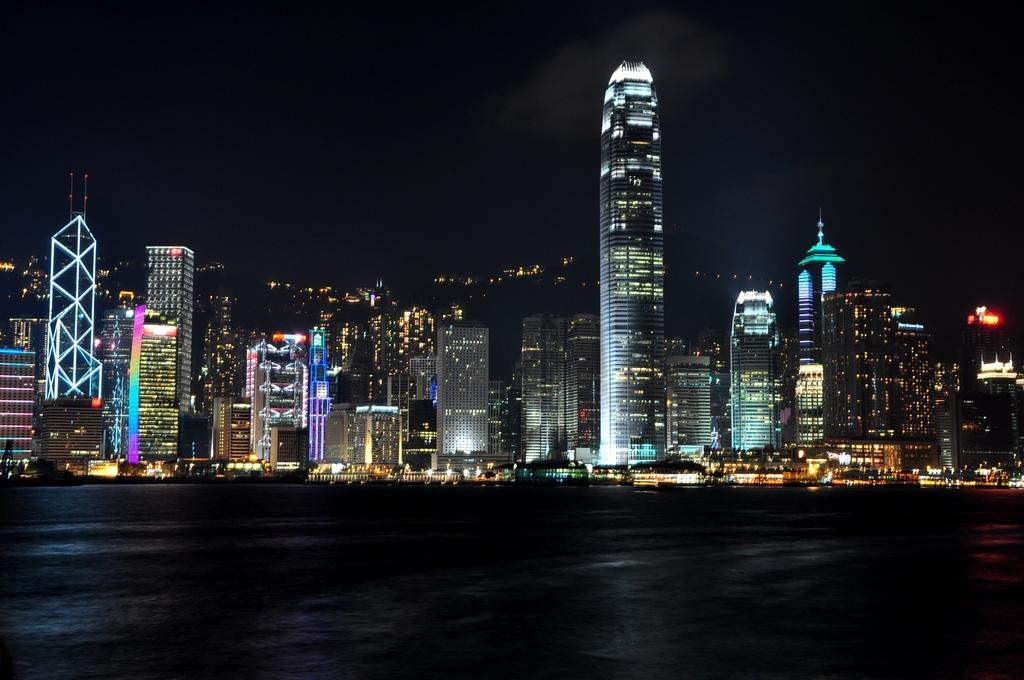What type of structures are present in the image? There are buildings with lights in the image. What can be seen in front of the buildings? There is water visible in front of the buildings. Where is the rabbit playing in the garden in the image? There is no rabbit or garden present in the image. 